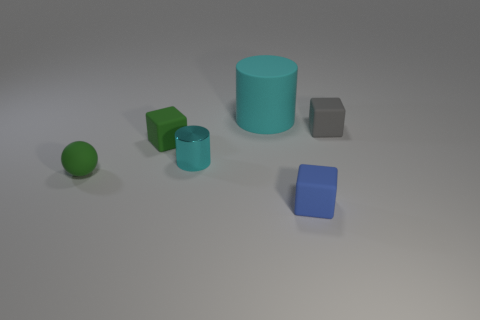Is there any other thing that is the same size as the cyan matte object?
Provide a short and direct response. No. Is there any other thing that is made of the same material as the small cyan cylinder?
Ensure brevity in your answer.  No. There is another object that is the same color as the tiny shiny thing; what size is it?
Give a very brief answer. Large. What is the material of the large cyan object?
Offer a terse response. Rubber. There is a ball that is the same size as the gray block; what is its color?
Your response must be concise. Green. There is a small rubber object that is the same color as the ball; what is its shape?
Your response must be concise. Cube. Is the shape of the tiny blue object the same as the large cyan thing?
Offer a very short reply. No. There is a thing that is right of the large object and behind the green block; what is it made of?
Offer a terse response. Rubber. The green sphere has what size?
Provide a succinct answer. Small. What is the color of the other tiny thing that is the same shape as the cyan matte object?
Give a very brief answer. Cyan. 